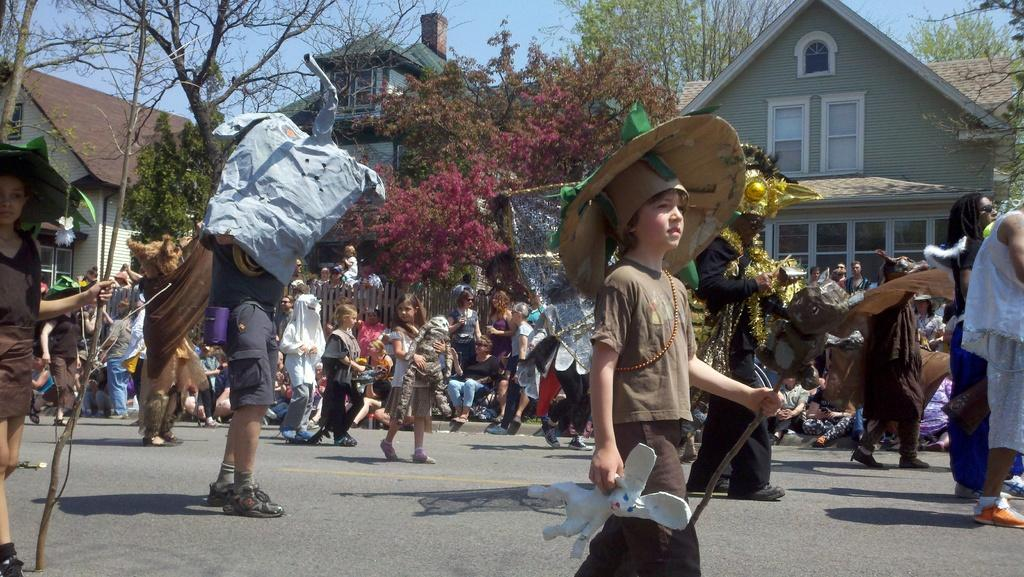How many people are in the image? There is a group of people in the image, but the exact number is not specified. What are some of the people in the image doing? Some people are walking on the road. What can be seen in the background of the image? There are trees, a fence, buildings with windows, and the sky visible in the background of the image. What type of objects are present in the image? The specific objects are not mentioned, but we know that there are objects in the image. What type of soda is being served at the zebra's interest in the image? There is no zebra or soda present in the image, and therefore no such activity or interest can be observed. 